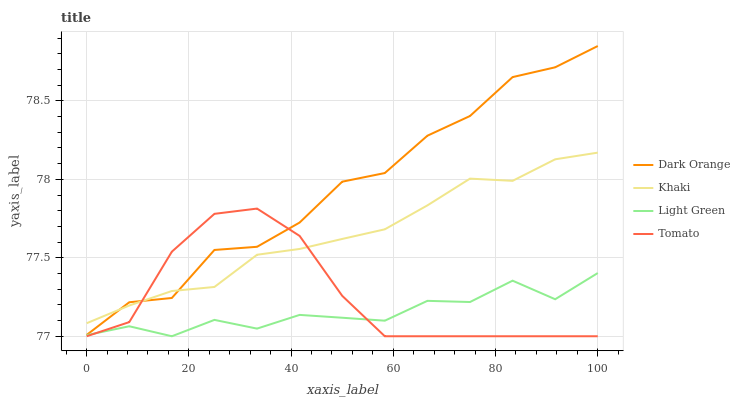Does Light Green have the minimum area under the curve?
Answer yes or no. Yes. Does Dark Orange have the maximum area under the curve?
Answer yes or no. Yes. Does Khaki have the minimum area under the curve?
Answer yes or no. No. Does Khaki have the maximum area under the curve?
Answer yes or no. No. Is Khaki the smoothest?
Answer yes or no. Yes. Is Dark Orange the roughest?
Answer yes or no. Yes. Is Dark Orange the smoothest?
Answer yes or no. No. Is Khaki the roughest?
Answer yes or no. No. Does Dark Orange have the lowest value?
Answer yes or no. No. Does Dark Orange have the highest value?
Answer yes or no. Yes. Does Khaki have the highest value?
Answer yes or no. No. Is Light Green less than Khaki?
Answer yes or no. Yes. Is Khaki greater than Light Green?
Answer yes or no. Yes. Does Light Green intersect Khaki?
Answer yes or no. No. 